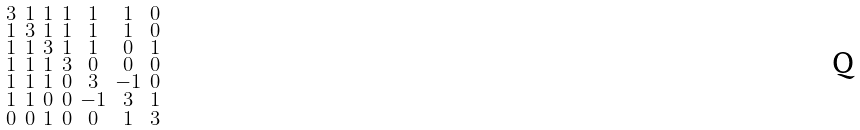<formula> <loc_0><loc_0><loc_500><loc_500>\begin{smallmatrix} 3 & 1 & 1 & 1 & 1 & 1 & 0 \\ 1 & 3 & 1 & 1 & 1 & 1 & 0 \\ 1 & 1 & 3 & 1 & 1 & 0 & 1 \\ 1 & 1 & 1 & 3 & 0 & 0 & 0 \\ 1 & 1 & 1 & 0 & 3 & - 1 & 0 \\ 1 & 1 & 0 & 0 & - 1 & 3 & 1 \\ 0 & 0 & 1 & 0 & 0 & 1 & 3 \end{smallmatrix}</formula> 